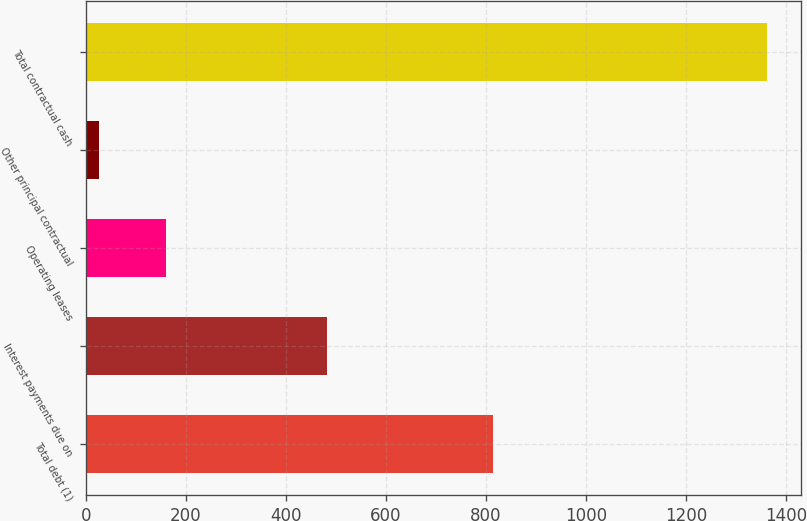Convert chart. <chart><loc_0><loc_0><loc_500><loc_500><bar_chart><fcel>Total debt (1)<fcel>Interest payments due on<fcel>Operating leases<fcel>Other principal contractual<fcel>Total contractual cash<nl><fcel>814.4<fcel>481.5<fcel>159.64<fcel>26.1<fcel>1361.5<nl></chart> 